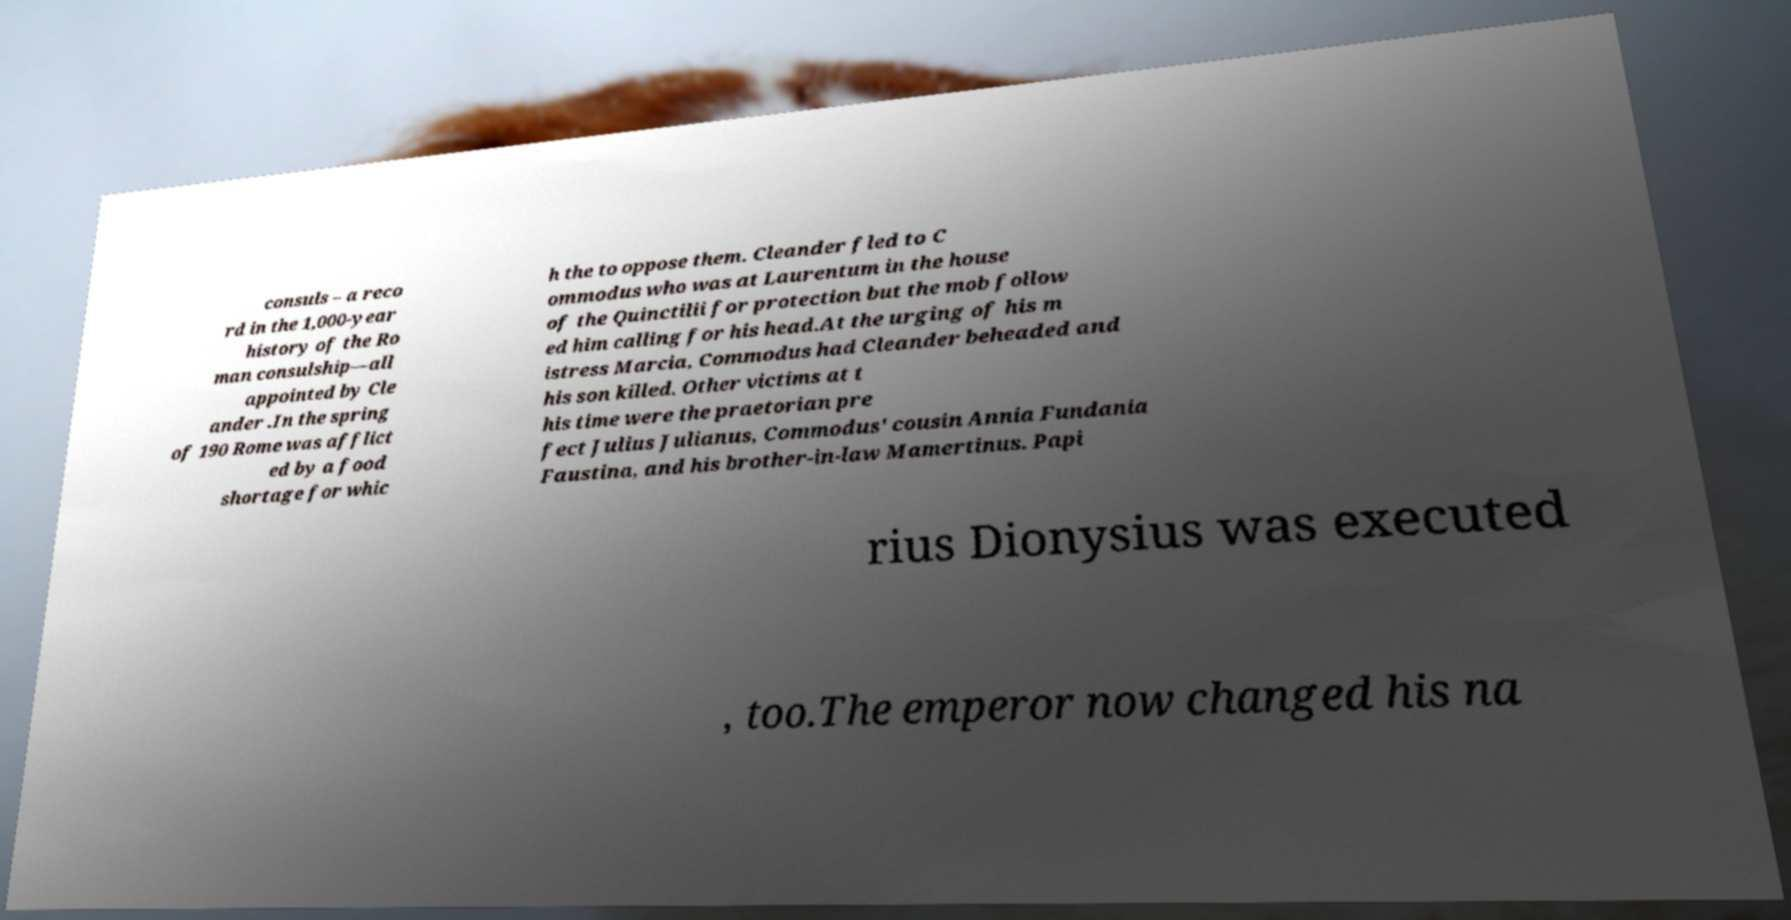What messages or text are displayed in this image? I need them in a readable, typed format. consuls – a reco rd in the 1,000-year history of the Ro man consulship—all appointed by Cle ander .In the spring of 190 Rome was afflict ed by a food shortage for whic h the to oppose them. Cleander fled to C ommodus who was at Laurentum in the house of the Quinctilii for protection but the mob follow ed him calling for his head.At the urging of his m istress Marcia, Commodus had Cleander beheaded and his son killed. Other victims at t his time were the praetorian pre fect Julius Julianus, Commodus' cousin Annia Fundania Faustina, and his brother-in-law Mamertinus. Papi rius Dionysius was executed , too.The emperor now changed his na 